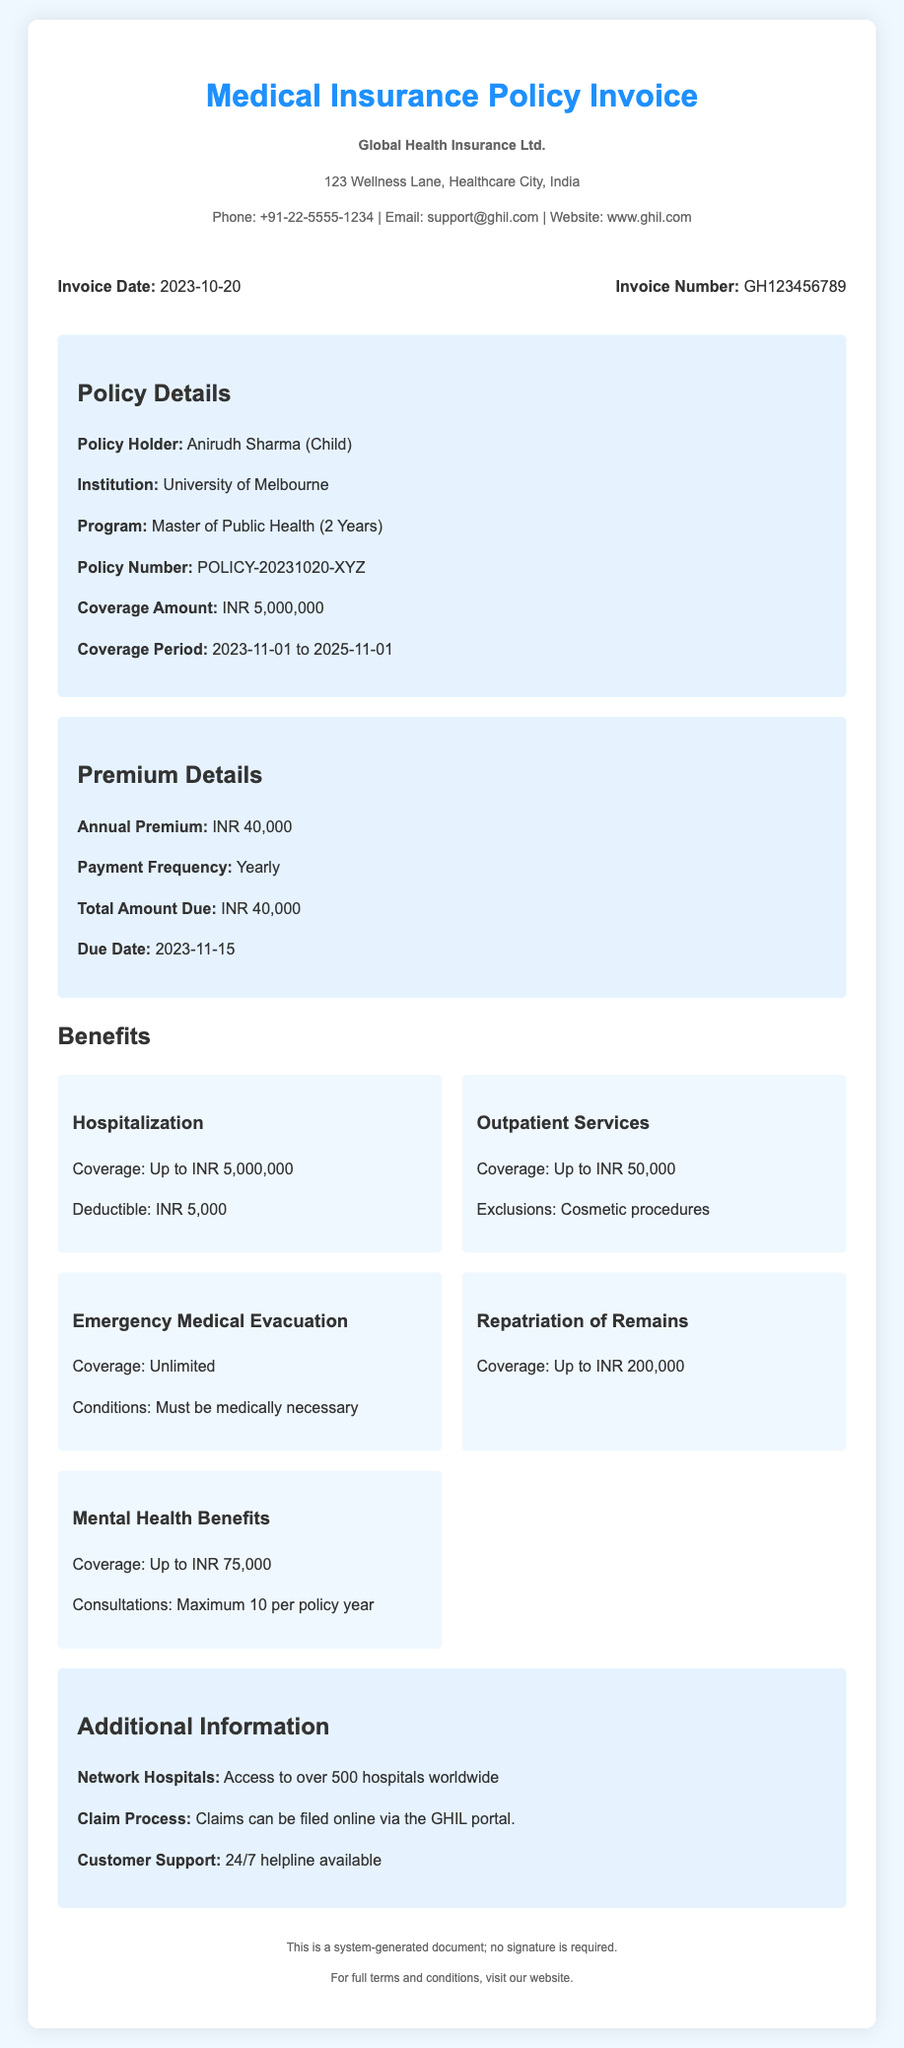What is the invoice date? The invoice date is stated clearly in the document as the date it was issued, which is 2023-10-20.
Answer: 2023-10-20 What is the policy holder's name? The policy holder's name is mentioned in the policy details section, specifically as Anirudh Sharma.
Answer: Anirudh Sharma What is the annual premium? The annual premium is specified in the premium details section, stating the yearly cost of the insurance policy.
Answer: INR 40,000 What is the total amount due? The total amount due is indicated in the premium details, which shows how much needs to be paid at the specified due date.
Answer: INR 40,000 What is the coverage amount? The coverage amount is detailed in the policy information, denoting the maximum sum that can be claimed under this policy.
Answer: INR 5,000,000 What are the coverage dates? The coverage dates outline the period for which the insurance is valid, detailed in the policy specifications.
Answer: 2023-11-01 to 2025-11-01 How many maximum consultations are included for mental health benefits? This refers to the limitations on mental health consultations as outlined under the benefits section of the document.
Answer: Maximum 10 per policy year What kind of support is available for customers? This information describes the customer service options provided, emphasizing availability and types of assistance offered.
Answer: 24/7 helpline available What is the deductible for hospitalization? This refers to the amount that must be paid out-of-pocket before the insurance begins to cover expenses as listed in the benefits section.
Answer: INR 5,000 